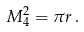<formula> <loc_0><loc_0><loc_500><loc_500>M ^ { 2 } _ { 4 } = \pi r \, .</formula> 